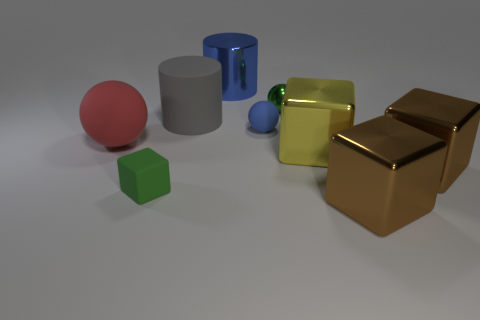Add 1 yellow metal objects. How many objects exist? 10 Subtract all cylinders. How many objects are left? 7 Subtract all tiny gray objects. Subtract all matte cubes. How many objects are left? 8 Add 1 large blue things. How many large blue things are left? 2 Add 2 balls. How many balls exist? 5 Subtract 1 green blocks. How many objects are left? 8 